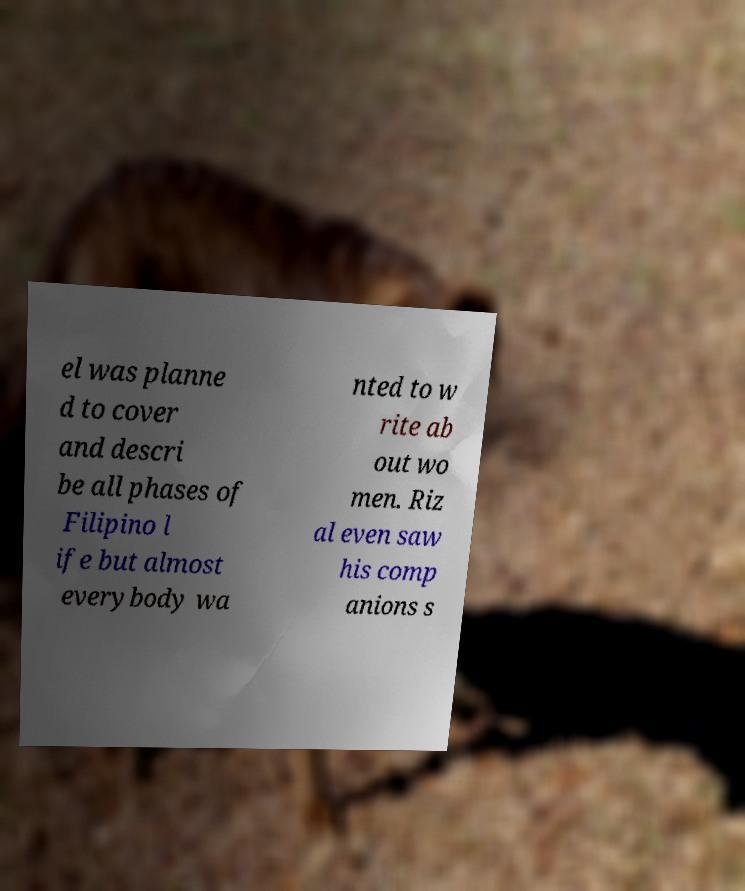Please identify and transcribe the text found in this image. el was planne d to cover and descri be all phases of Filipino l ife but almost everybody wa nted to w rite ab out wo men. Riz al even saw his comp anions s 